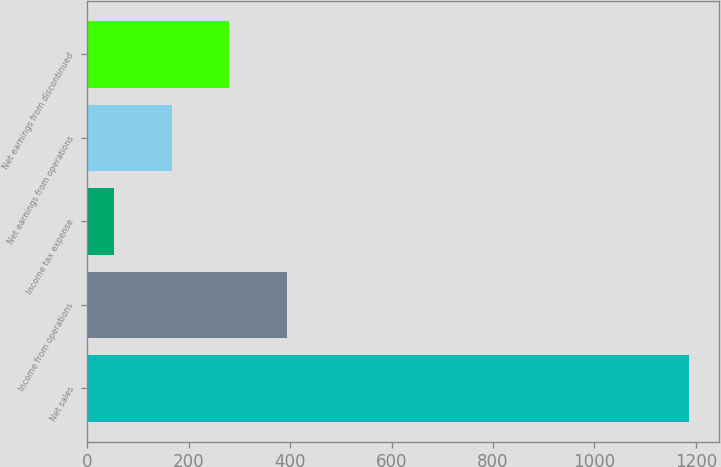Convert chart to OTSL. <chart><loc_0><loc_0><loc_500><loc_500><bar_chart><fcel>Net sales<fcel>Income from operations<fcel>Income tax expense<fcel>Net earnings from operations<fcel>Net earnings from discontinued<nl><fcel>1186<fcel>392.9<fcel>53<fcel>166.3<fcel>279.6<nl></chart> 